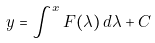Convert formula to latex. <formula><loc_0><loc_0><loc_500><loc_500>y = \int ^ { x } F ( \lambda ) \, d \lambda + C \,</formula> 